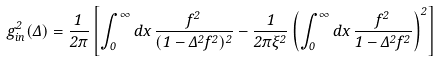Convert formula to latex. <formula><loc_0><loc_0><loc_500><loc_500>g ^ { 2 } _ { i n } ( \Delta ) = \frac { 1 } { 2 \pi } \left [ \int _ { 0 } ^ { \infty } d x \, \frac { f ^ { 2 } } { ( 1 - \Delta ^ { 2 } f ^ { 2 } ) ^ { 2 } } - \frac { 1 } { 2 \pi \xi ^ { 2 } } \left ( \int _ { 0 } ^ { \infty } d x \, \frac { f ^ { 2 } } { 1 - \Delta ^ { 2 } f ^ { 2 } } \right ) ^ { 2 } \right ]</formula> 